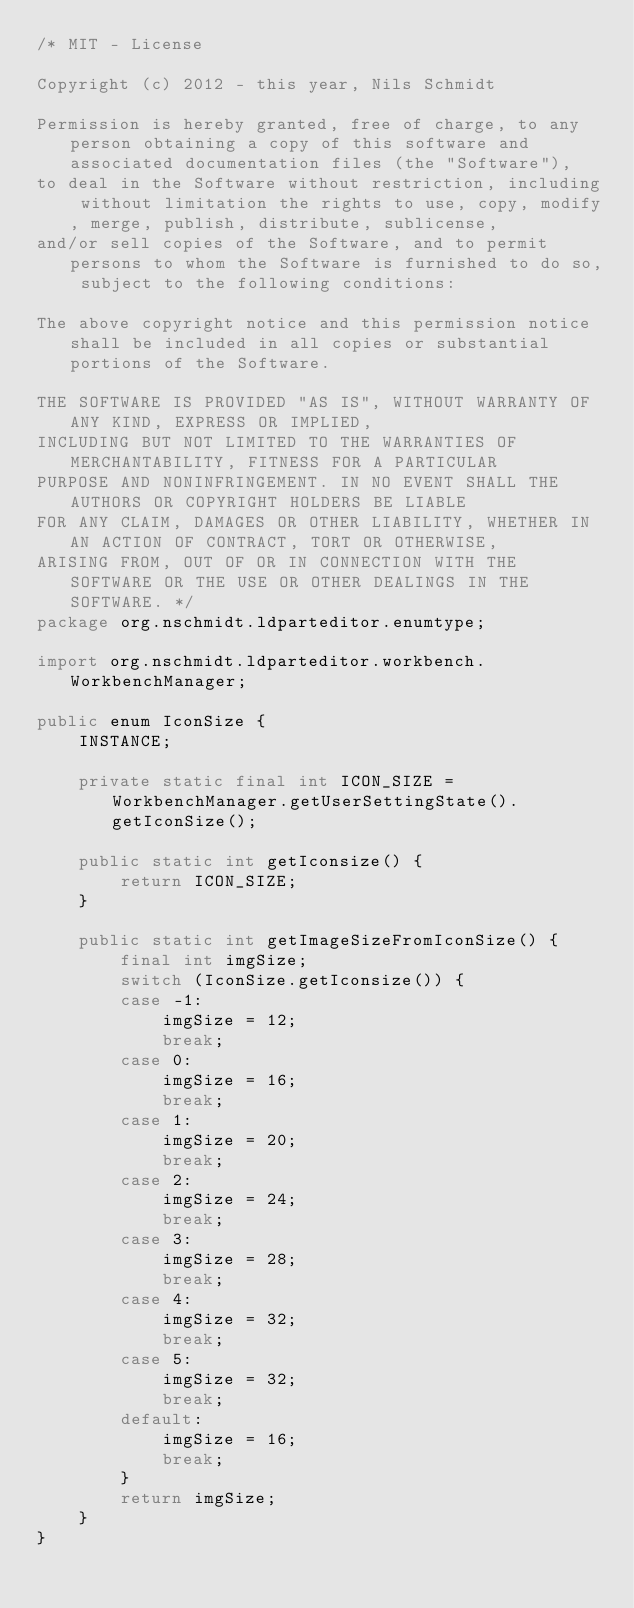<code> <loc_0><loc_0><loc_500><loc_500><_Java_>/* MIT - License

Copyright (c) 2012 - this year, Nils Schmidt

Permission is hereby granted, free of charge, to any person obtaining a copy of this software and associated documentation files (the "Software"),
to deal in the Software without restriction, including without limitation the rights to use, copy, modify, merge, publish, distribute, sublicense,
and/or sell copies of the Software, and to permit persons to whom the Software is furnished to do so, subject to the following conditions:

The above copyright notice and this permission notice shall be included in all copies or substantial portions of the Software.

THE SOFTWARE IS PROVIDED "AS IS", WITHOUT WARRANTY OF ANY KIND, EXPRESS OR IMPLIED,
INCLUDING BUT NOT LIMITED TO THE WARRANTIES OF MERCHANTABILITY, FITNESS FOR A PARTICULAR
PURPOSE AND NONINFRINGEMENT. IN NO EVENT SHALL THE AUTHORS OR COPYRIGHT HOLDERS BE LIABLE
FOR ANY CLAIM, DAMAGES OR OTHER LIABILITY, WHETHER IN AN ACTION OF CONTRACT, TORT OR OTHERWISE,
ARISING FROM, OUT OF OR IN CONNECTION WITH THE SOFTWARE OR THE USE OR OTHER DEALINGS IN THE SOFTWARE. */
package org.nschmidt.ldparteditor.enumtype;

import org.nschmidt.ldparteditor.workbench.WorkbenchManager;

public enum IconSize {
    INSTANCE;

    private static final int ICON_SIZE = WorkbenchManager.getUserSettingState().getIconSize();

    public static int getIconsize() {
        return ICON_SIZE;
    }

    public static int getImageSizeFromIconSize() {
        final int imgSize;
        switch (IconSize.getIconsize()) {
        case -1:
            imgSize = 12;
            break;
        case 0:
            imgSize = 16;
            break;
        case 1:
            imgSize = 20;
            break;
        case 2:
            imgSize = 24;
            break;
        case 3:
            imgSize = 28;
            break;
        case 4:
            imgSize = 32;
            break;
        case 5:
            imgSize = 32;
            break;
        default:
            imgSize = 16;
            break;
        }
        return imgSize;
    }
}
</code> 